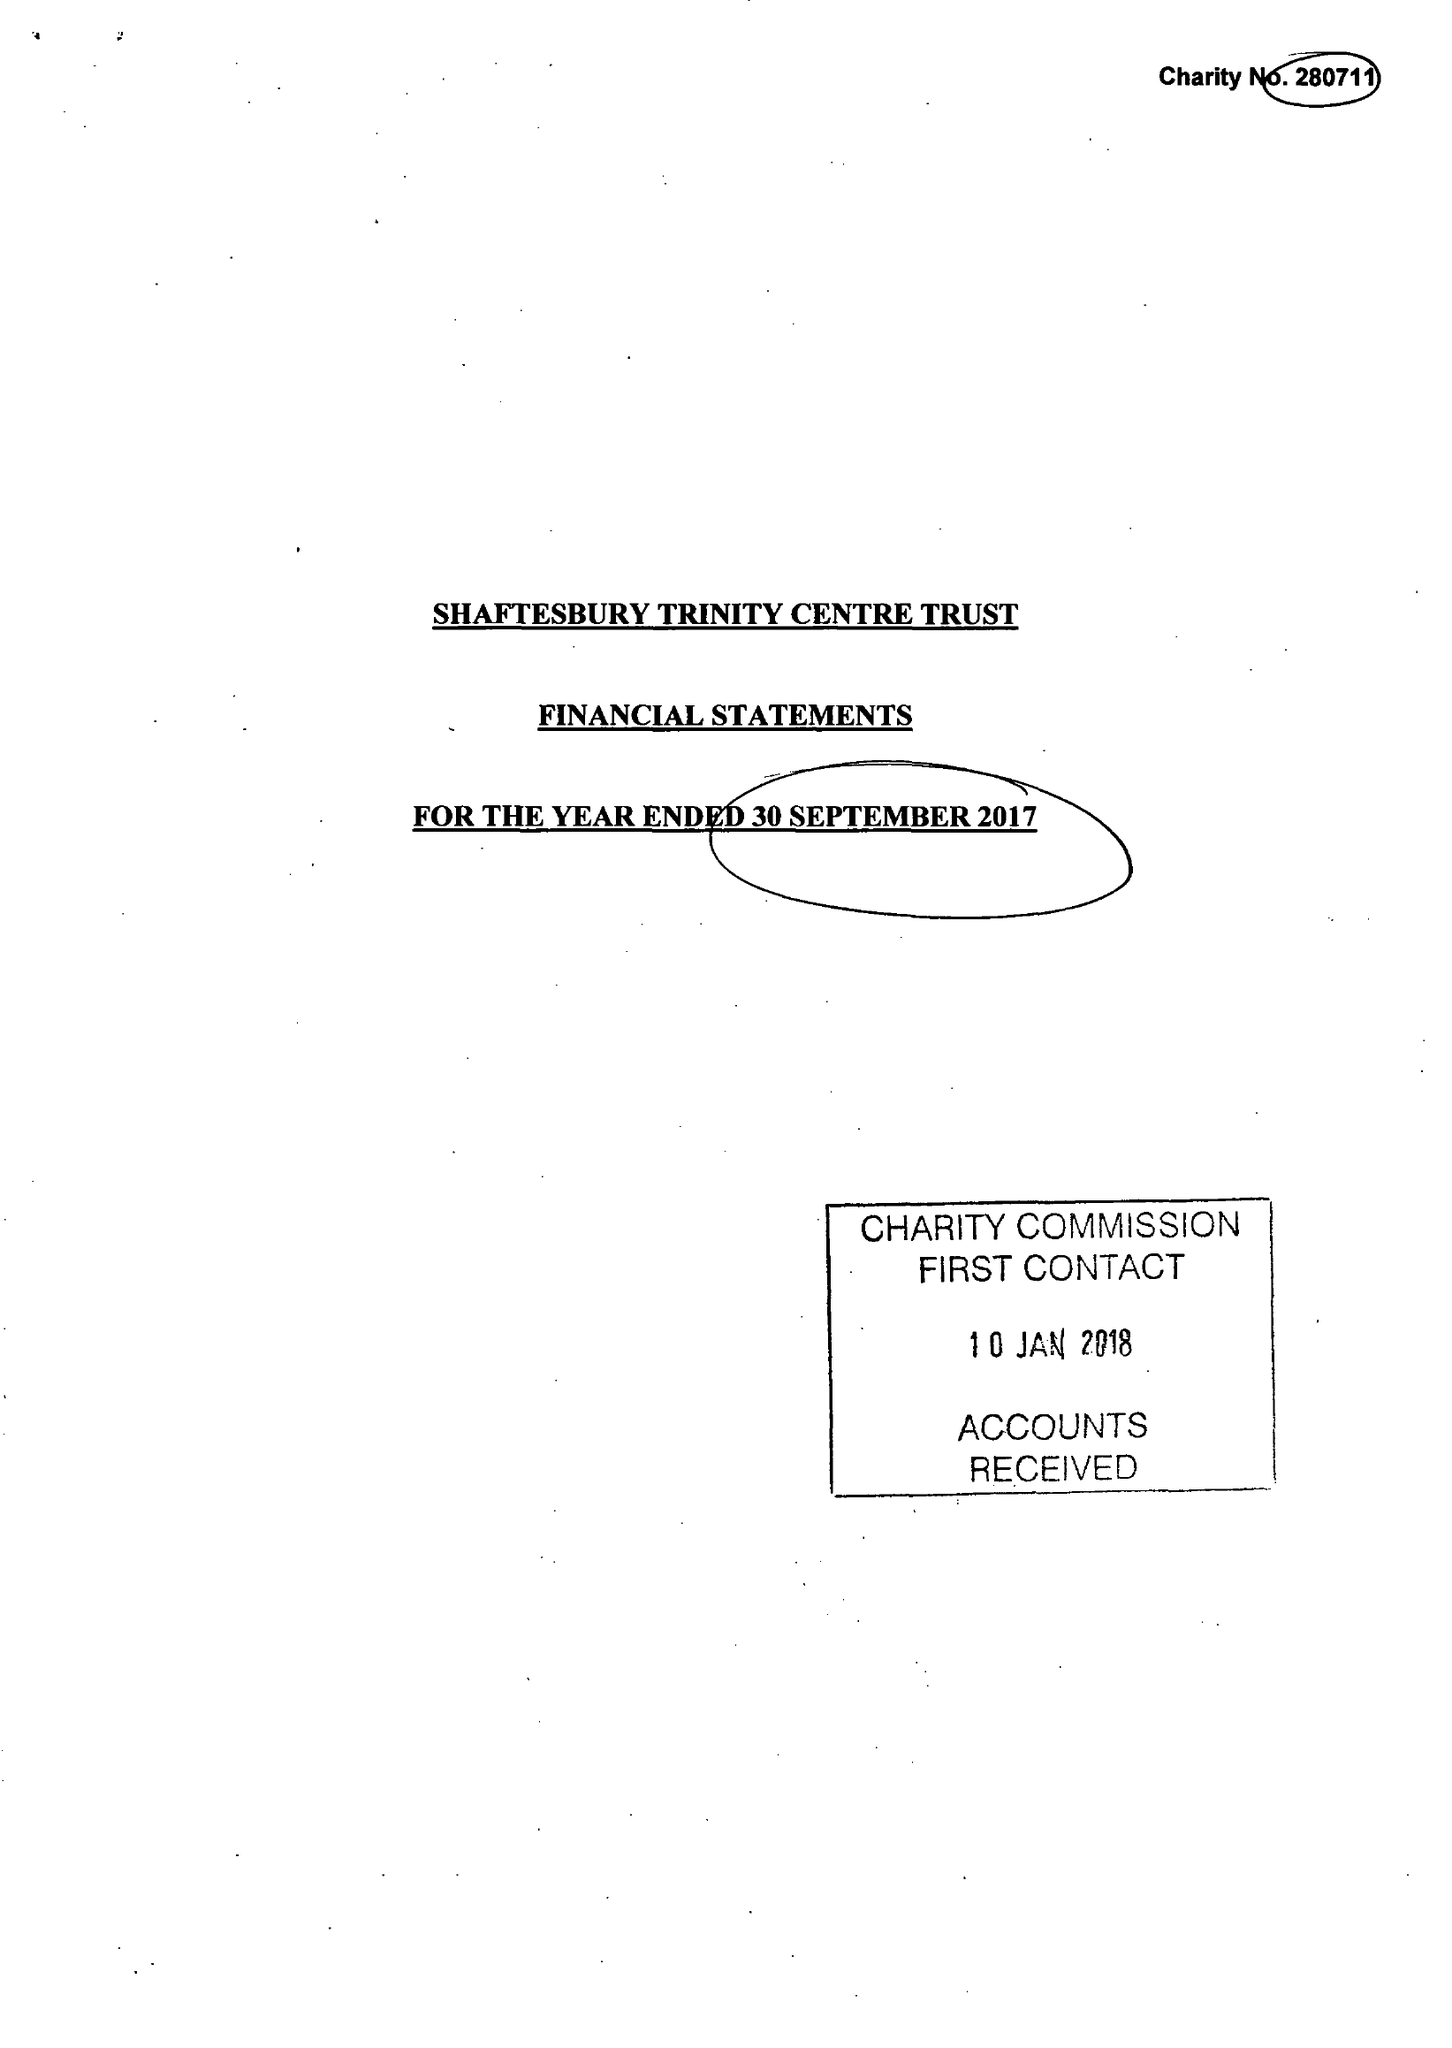What is the value for the address__postcode?
Answer the question using a single word or phrase. SP8 5JH 